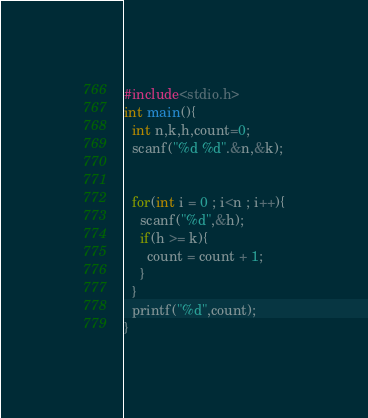<code> <loc_0><loc_0><loc_500><loc_500><_C_>#include<stdio.h>
int main(){
  int n,k,h,count=0;
  scanf("%d %d".&n,&k);
  
  
  for(int i = 0 ; i<n ; i++){
    scanf("%d",&h);
    if(h >= k){
      count = count + 1;
    }
  }
  printf("%d",count);
}</code> 